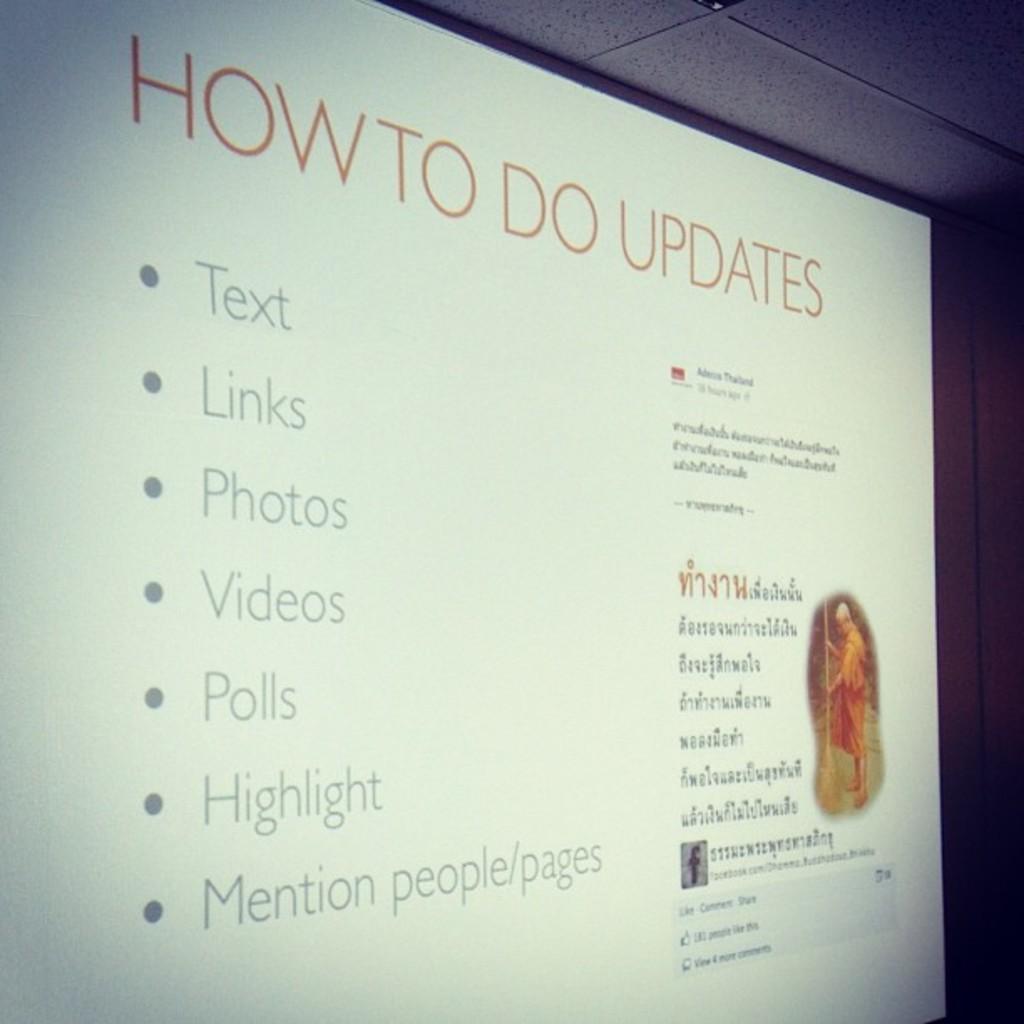What is the first word on top left?
Your answer should be compact. How. 